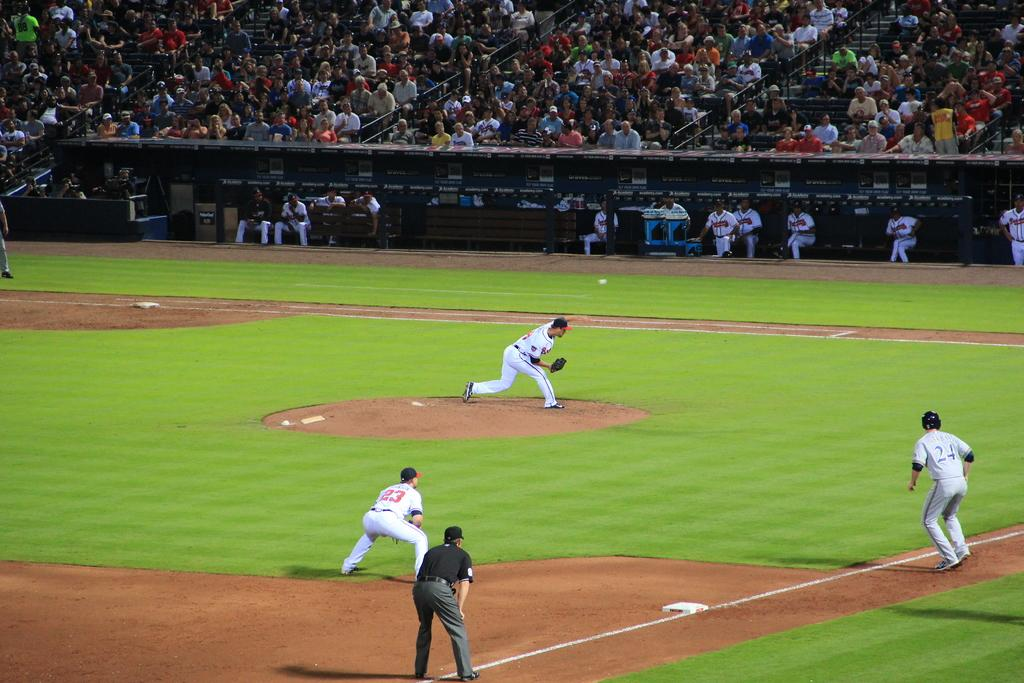<image>
Offer a succinct explanation of the picture presented. Baseball players on the field with number 24 preparing to run. 